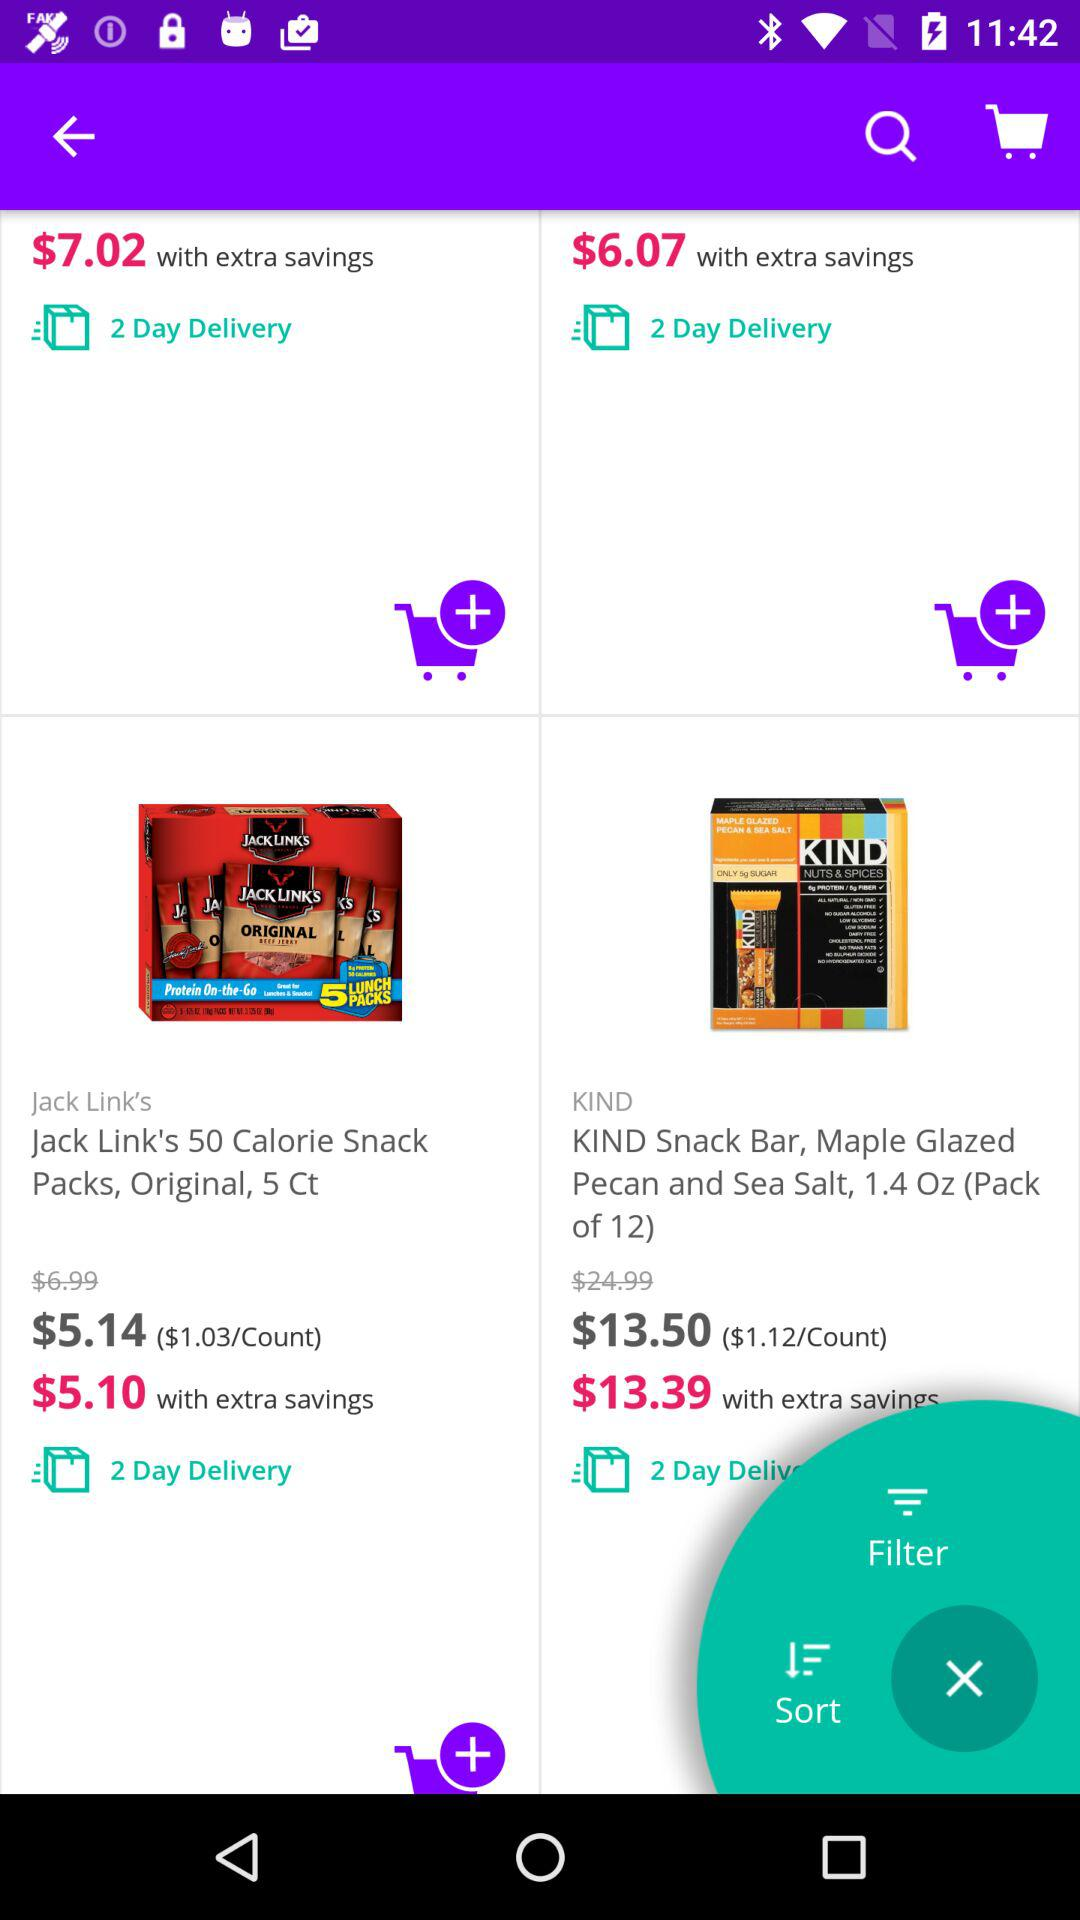What is the price of the "Jack Link's 50 Calorie Snack Pack, Original, 5 Ct"? The price of the "Jack Link's 50 Calorie Snack Pack, Original, 5 Ct" is 5.14 dollars. 